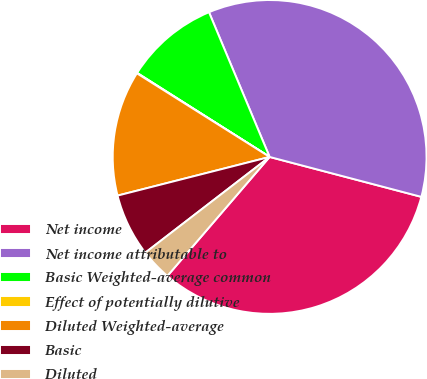<chart> <loc_0><loc_0><loc_500><loc_500><pie_chart><fcel>Net income<fcel>Net income attributable to<fcel>Basic Weighted-average common<fcel>Effect of potentially dilutive<fcel>Diluted Weighted-average<fcel>Basic<fcel>Diluted<nl><fcel>32.2%<fcel>35.41%<fcel>9.69%<fcel>0.05%<fcel>12.91%<fcel>6.48%<fcel>3.26%<nl></chart> 